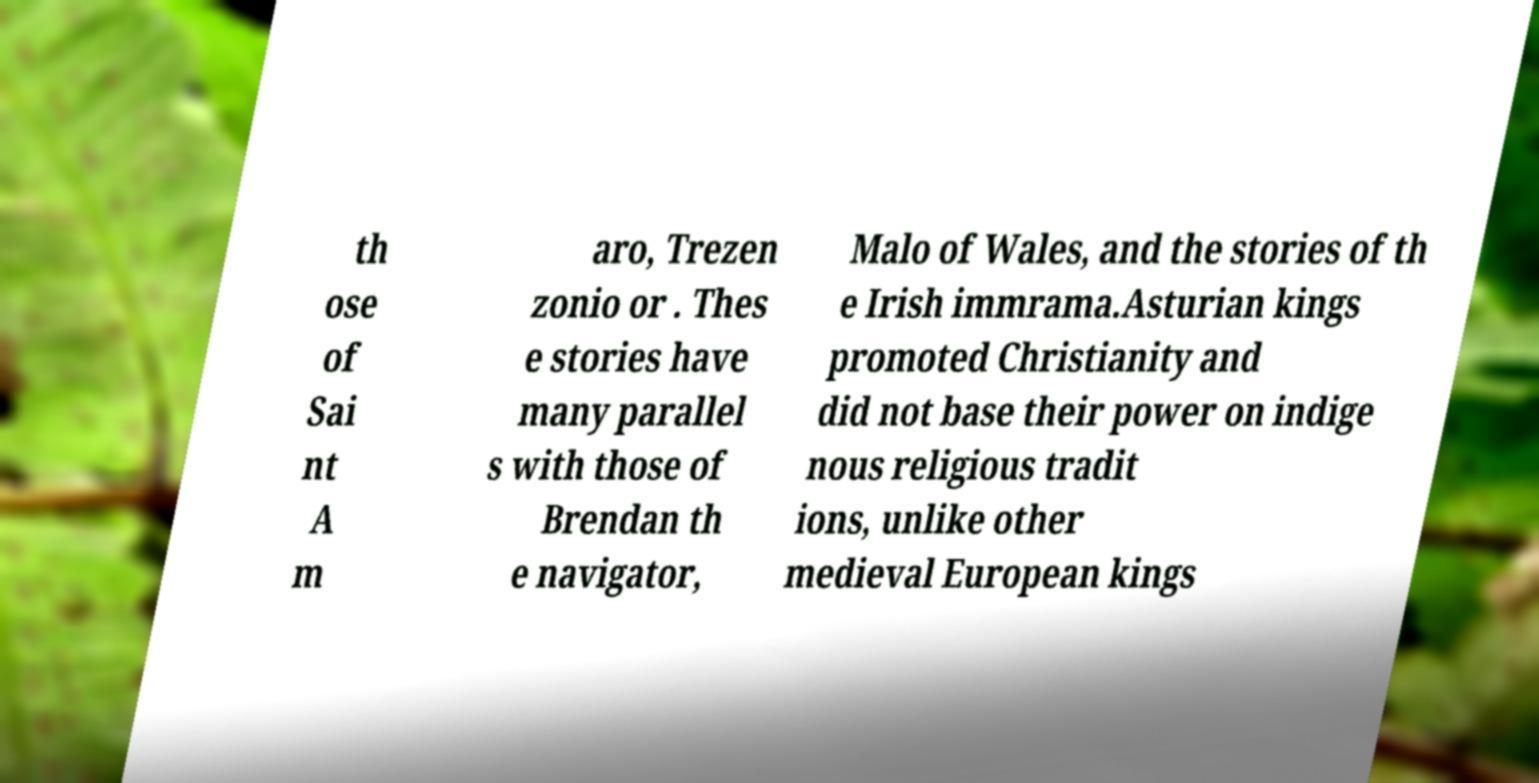Could you assist in decoding the text presented in this image and type it out clearly? th ose of Sai nt A m aro, Trezen zonio or . Thes e stories have many parallel s with those of Brendan th e navigator, Malo of Wales, and the stories of th e Irish immrama.Asturian kings promoted Christianity and did not base their power on indige nous religious tradit ions, unlike other medieval European kings 